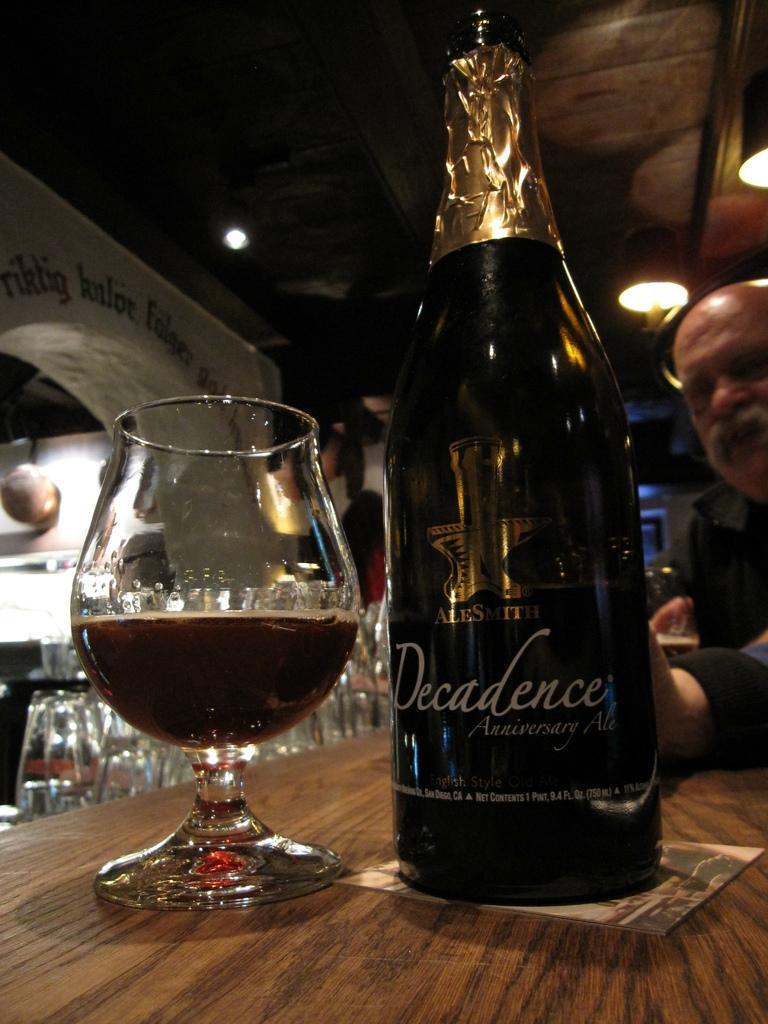Describe this image in one or two sentences. In this image in the front there is a bottle with some text written on it and there is a glass. In the background there are glasses and on the right side there is a person. On the top there are lights and on the left side there is a wall and on the wall there is some text written on it. 